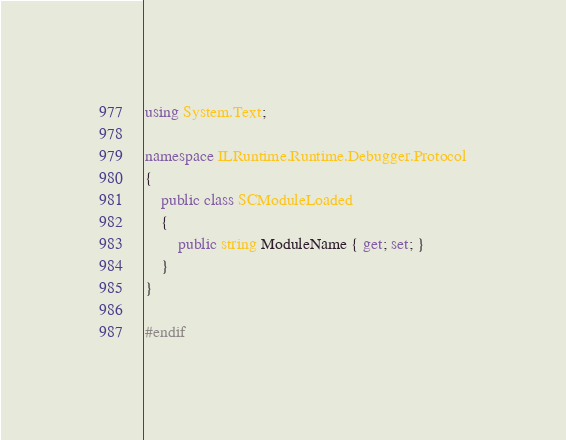<code> <loc_0><loc_0><loc_500><loc_500><_C#_>using System.Text;

namespace ILRuntime.Runtime.Debugger.Protocol
{
    public class SCModuleLoaded
    {
        public string ModuleName { get; set; }
    }
}
#endif</code> 